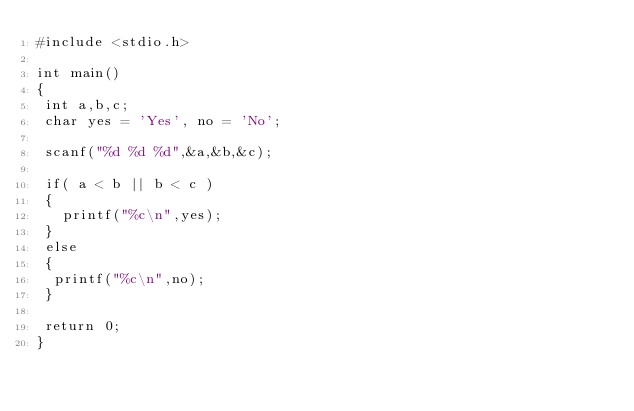Convert code to text. <code><loc_0><loc_0><loc_500><loc_500><_C_>#include <stdio.h>

int main()
{
 int a,b,c;
 char yes = 'Yes', no = 'No';
 
 scanf("%d %d %d",&a,&b,&c);
 
 if( a < b || b < c )
 { 
   printf("%c\n",yes);
 }
 else
 { 
  printf("%c\n",no);
 }
 
 return 0;
}</code> 